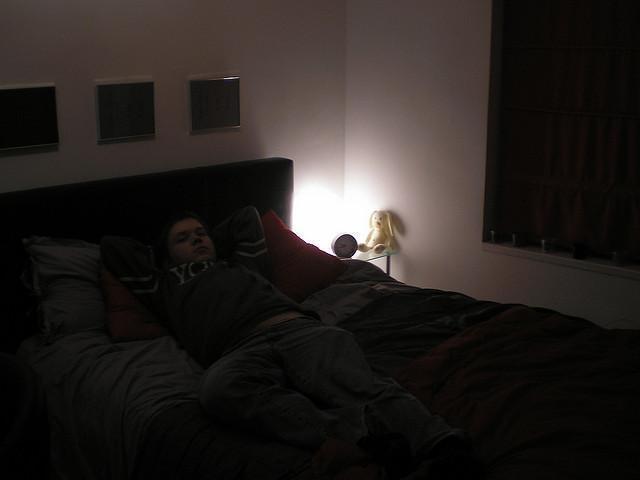The boy is most likely doing what?
Indicate the correct response by choosing from the four available options to answer the question.
Options: Cooking, dreaming, exercising, running. Dreaming. 